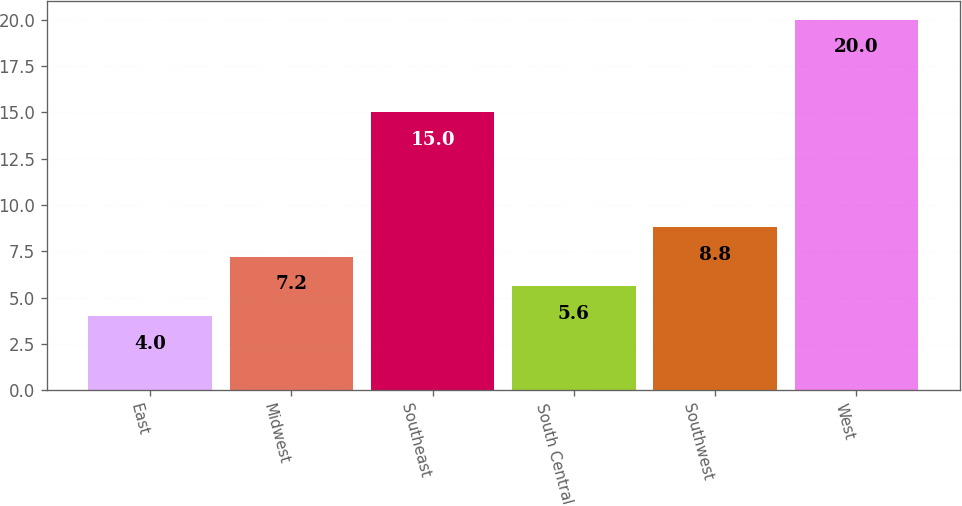<chart> <loc_0><loc_0><loc_500><loc_500><bar_chart><fcel>East<fcel>Midwest<fcel>Southeast<fcel>South Central<fcel>Southwest<fcel>West<nl><fcel>4<fcel>7.2<fcel>15<fcel>5.6<fcel>8.8<fcel>20<nl></chart> 